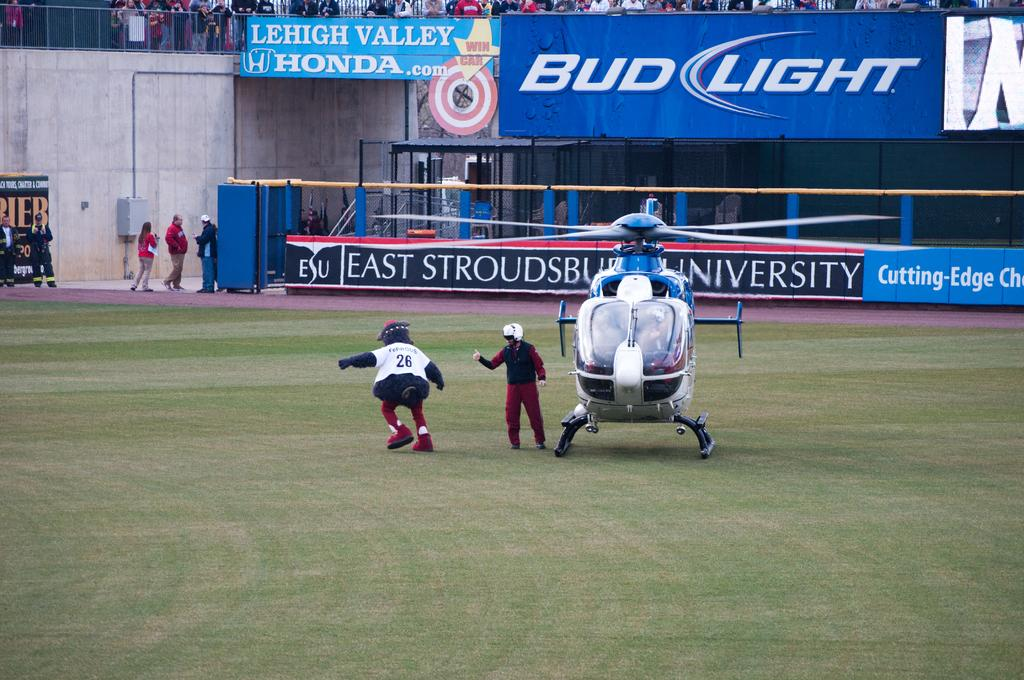<image>
Create a compact narrative representing the image presented. Helicopter on field of a baseball game with Bud Light as a sponsor. 